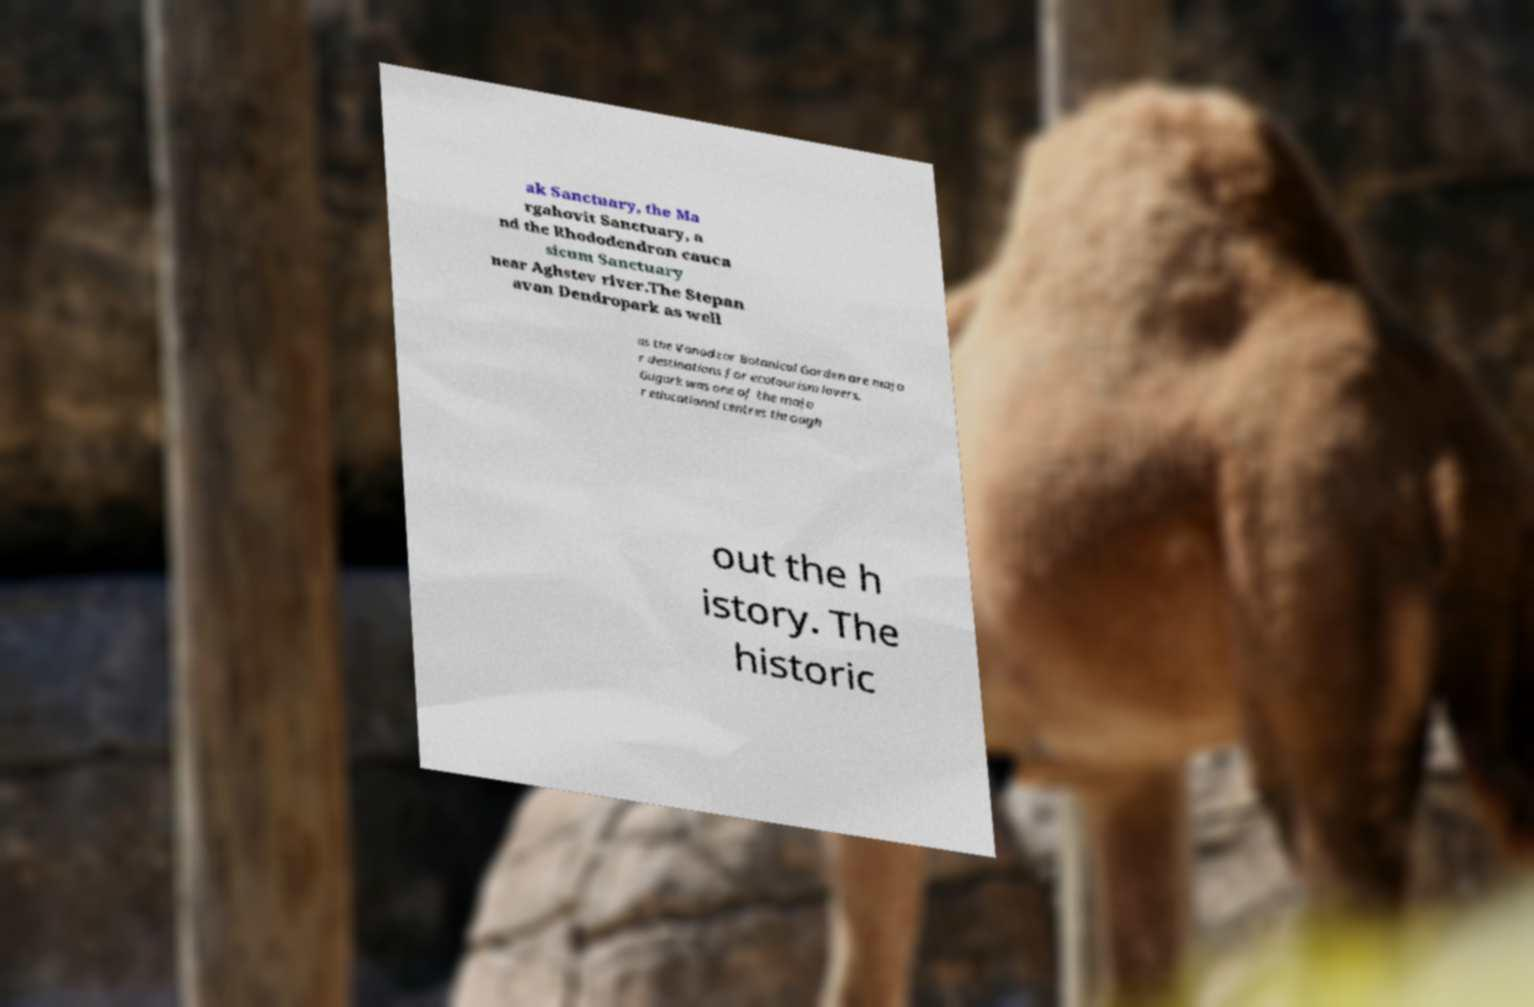I need the written content from this picture converted into text. Can you do that? ak Sanctuary, the Ma rgahovit Sanctuary, a nd the Rhododendron cauca sicum Sanctuary near Aghstev river.The Stepan avan Dendropark as well as the Vanadzor Botanical Garden are majo r destinations for ecotourism lovers. Gugark was one of the majo r educational centres through out the h istory. The historic 